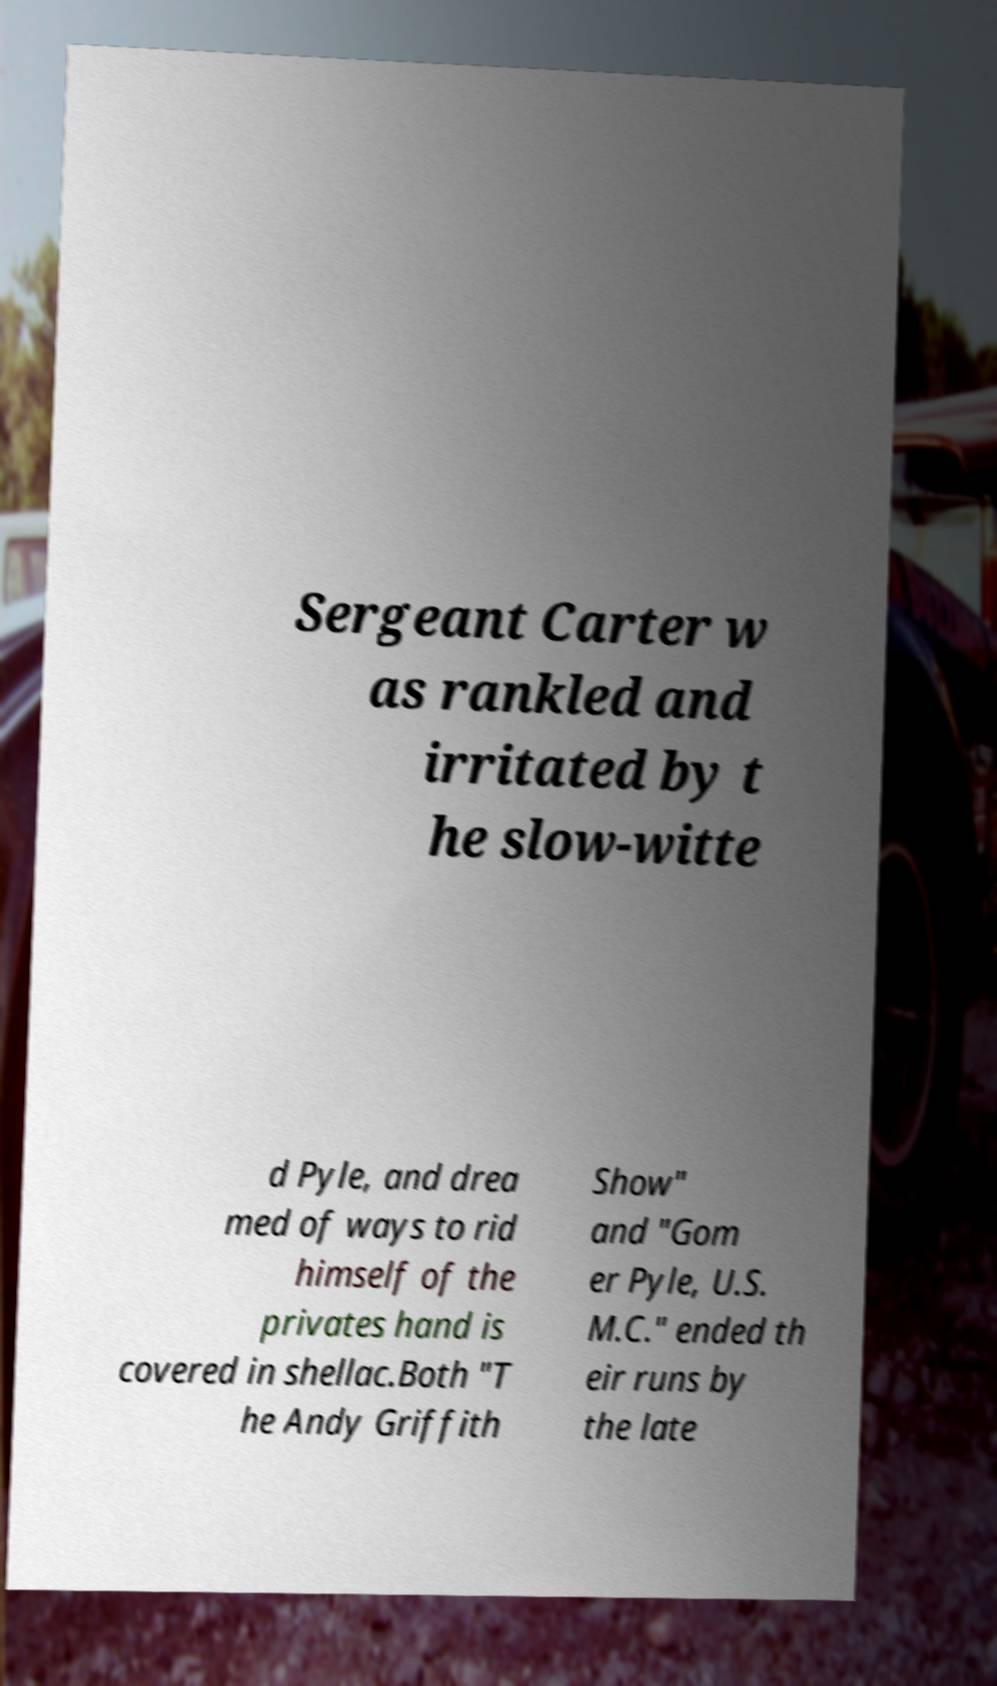What messages or text are displayed in this image? I need them in a readable, typed format. Sergeant Carter w as rankled and irritated by t he slow-witte d Pyle, and drea med of ways to rid himself of the privates hand is covered in shellac.Both "T he Andy Griffith Show" and "Gom er Pyle, U.S. M.C." ended th eir runs by the late 